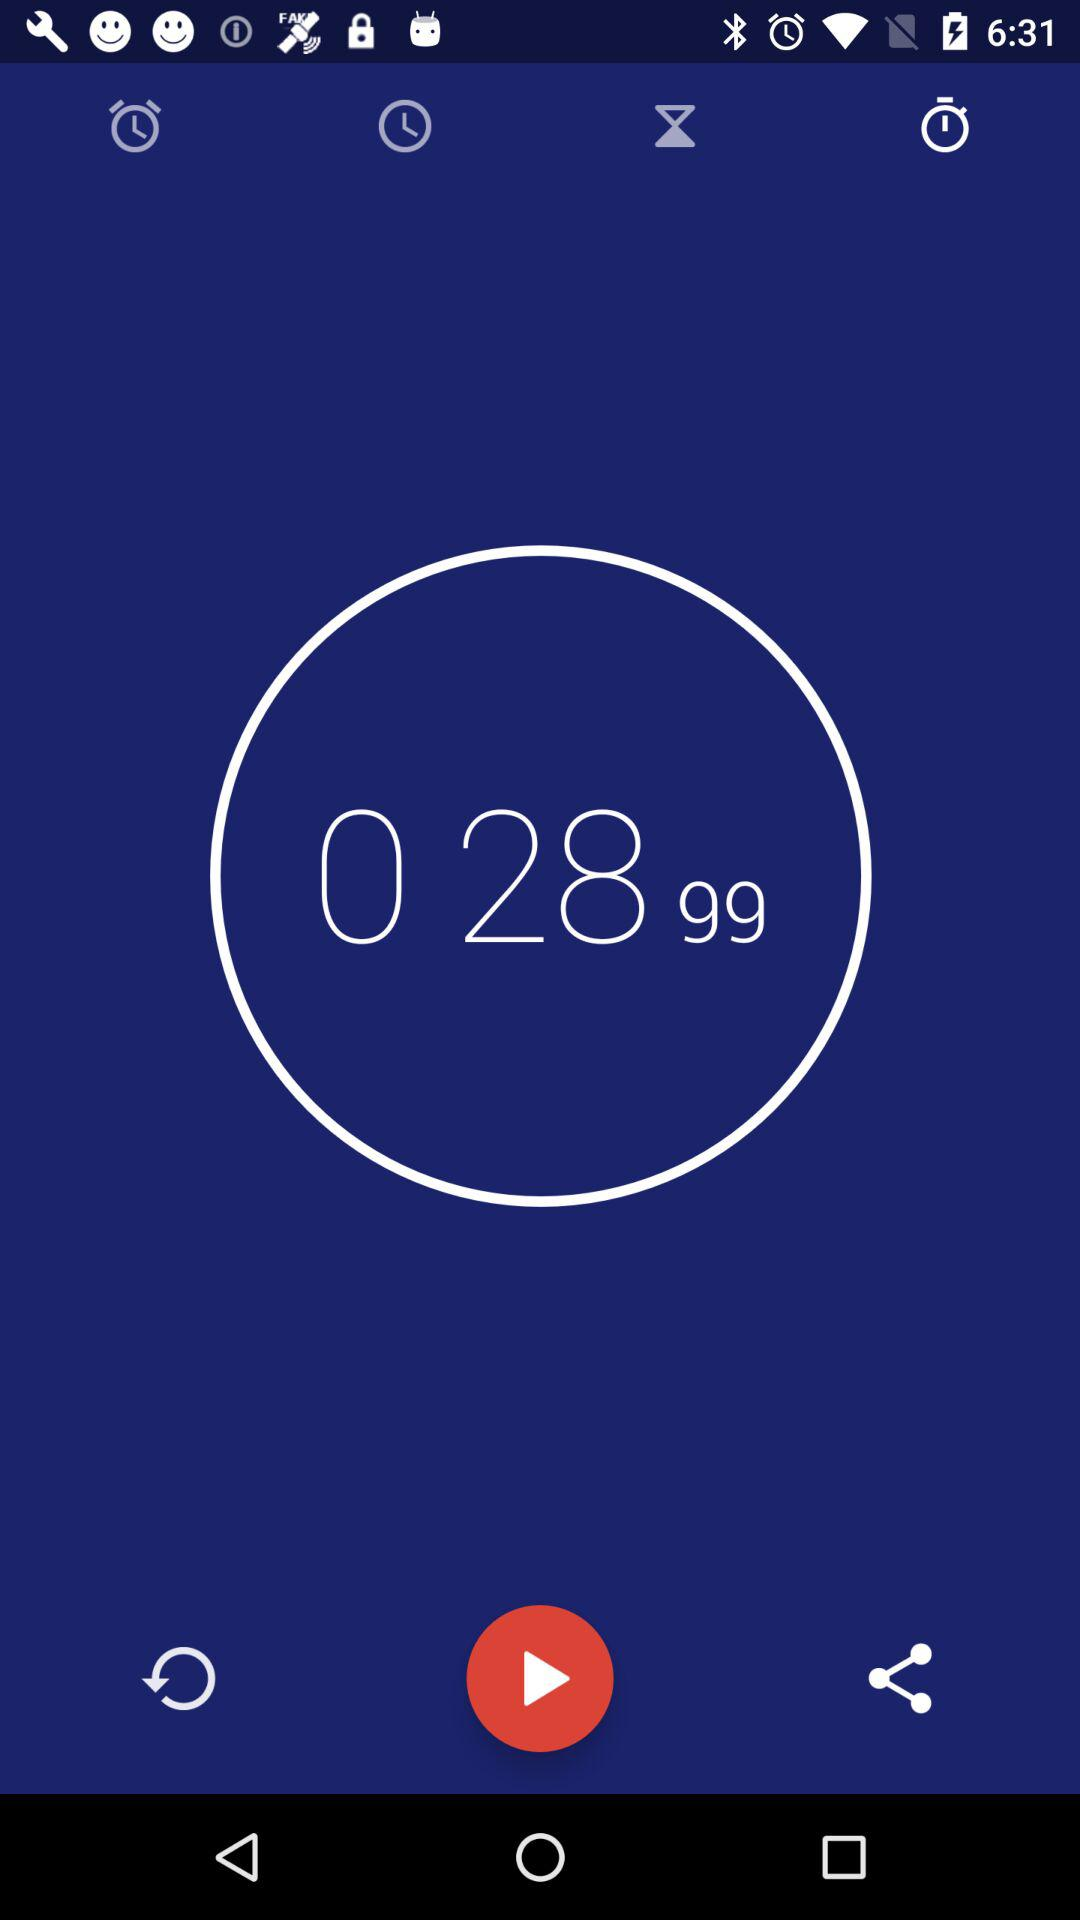What value is shown on the screen? The value is 0 28 99. 